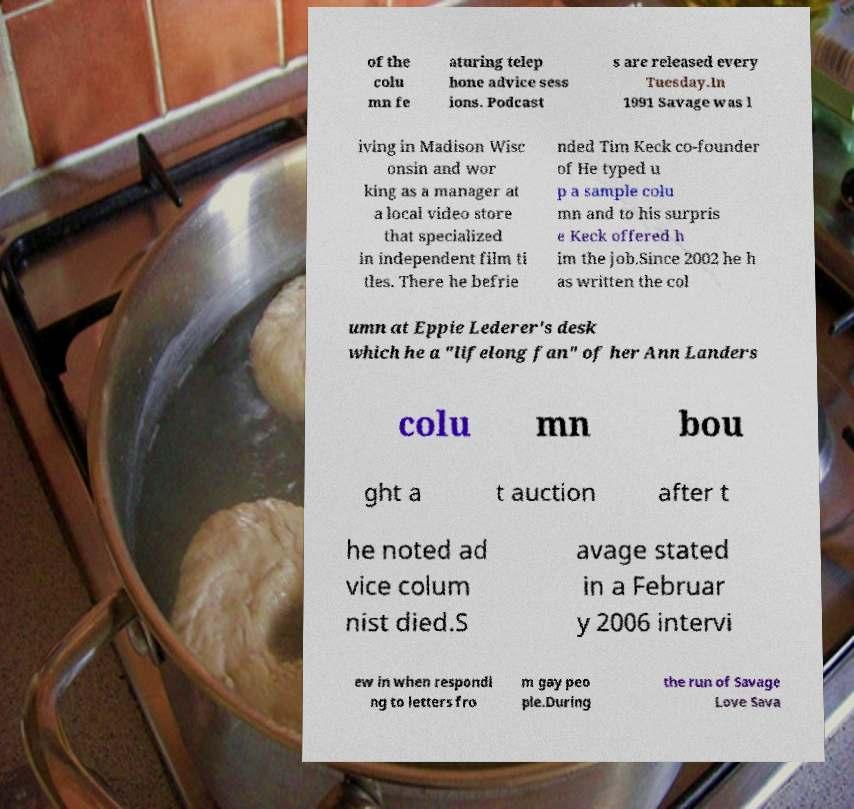Please identify and transcribe the text found in this image. of the colu mn fe aturing telep hone advice sess ions. Podcast s are released every Tuesday.In 1991 Savage was l iving in Madison Wisc onsin and wor king as a manager at a local video store that specialized in independent film ti tles. There he befrie nded Tim Keck co-founder of He typed u p a sample colu mn and to his surpris e Keck offered h im the job.Since 2002 he h as written the col umn at Eppie Lederer's desk which he a "lifelong fan" of her Ann Landers colu mn bou ght a t auction after t he noted ad vice colum nist died.S avage stated in a Februar y 2006 intervi ew in when respondi ng to letters fro m gay peo ple.During the run of Savage Love Sava 